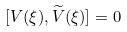Convert formula to latex. <formula><loc_0><loc_0><loc_500><loc_500>[ V ( \xi ) , { \widetilde { V } } ( \xi ) ] = 0</formula> 